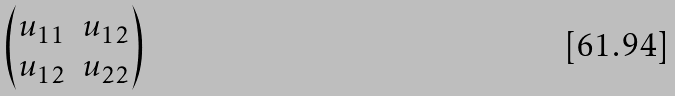Convert formula to latex. <formula><loc_0><loc_0><loc_500><loc_500>\begin{pmatrix} u _ { 1 1 } & u _ { 1 2 } \\ u _ { 1 2 } & u _ { 2 2 } \end{pmatrix}</formula> 